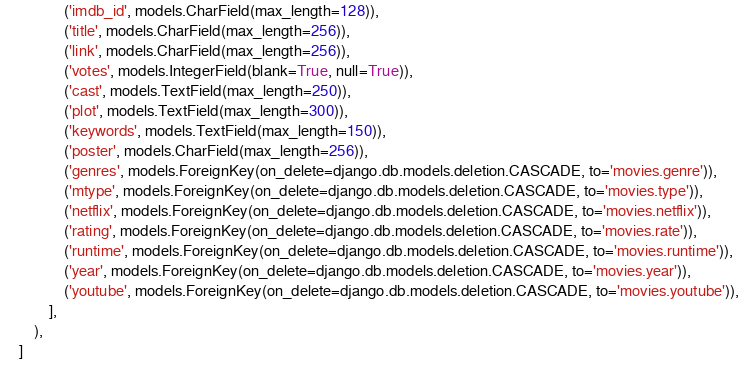<code> <loc_0><loc_0><loc_500><loc_500><_Python_>                ('imdb_id', models.CharField(max_length=128)),
                ('title', models.CharField(max_length=256)),
                ('link', models.CharField(max_length=256)),
                ('votes', models.IntegerField(blank=True, null=True)),
                ('cast', models.TextField(max_length=250)),
                ('plot', models.TextField(max_length=300)),
                ('keywords', models.TextField(max_length=150)),
                ('poster', models.CharField(max_length=256)),
                ('genres', models.ForeignKey(on_delete=django.db.models.deletion.CASCADE, to='movies.genre')),
                ('mtype', models.ForeignKey(on_delete=django.db.models.deletion.CASCADE, to='movies.type')),
                ('netflix', models.ForeignKey(on_delete=django.db.models.deletion.CASCADE, to='movies.netflix')),
                ('rating', models.ForeignKey(on_delete=django.db.models.deletion.CASCADE, to='movies.rate')),
                ('runtime', models.ForeignKey(on_delete=django.db.models.deletion.CASCADE, to='movies.runtime')),
                ('year', models.ForeignKey(on_delete=django.db.models.deletion.CASCADE, to='movies.year')),
                ('youtube', models.ForeignKey(on_delete=django.db.models.deletion.CASCADE, to='movies.youtube')),
            ],
        ),
    ]
</code> 